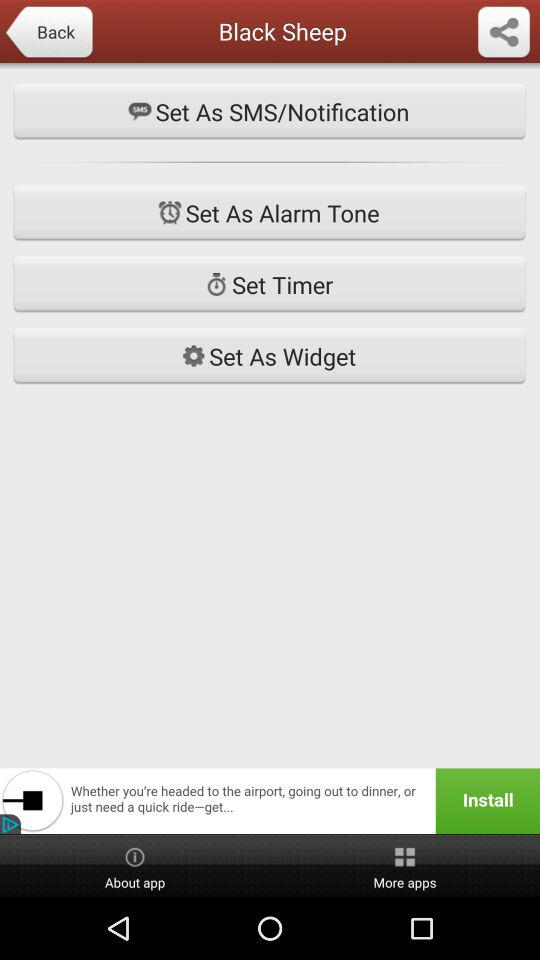What is the name of the application?
When the provided information is insufficient, respond with <no answer>. <no answer> 